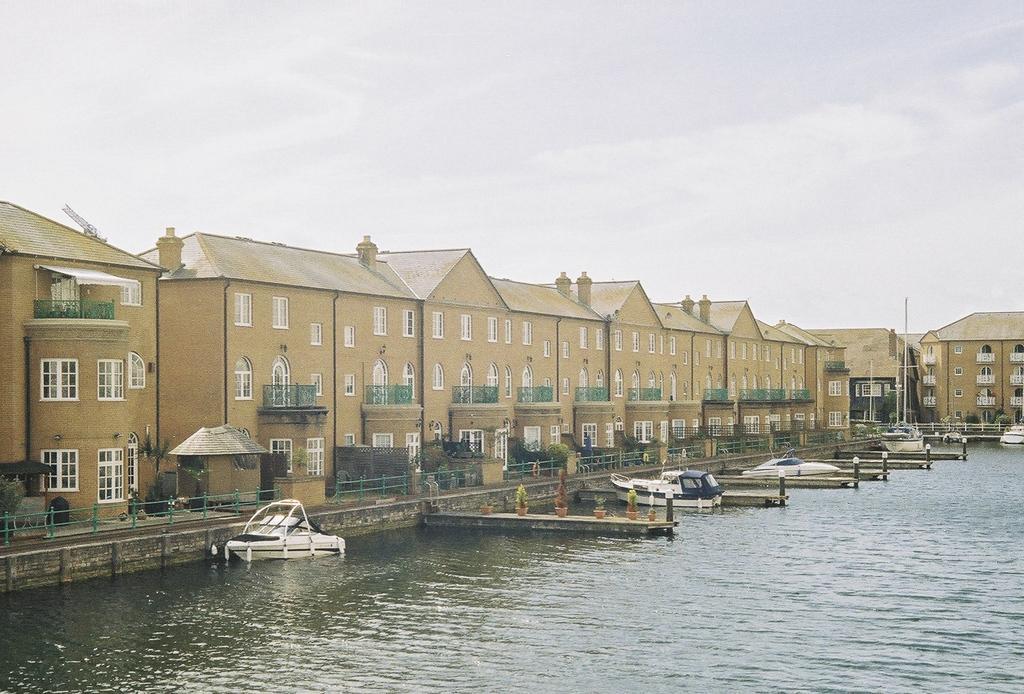Can you describe this image briefly? There is water. Also there are boats on the water. There are buildings with windows, balcony. Near to the buildings there is railing. Also there are pots with plants. In the background there is sky. 